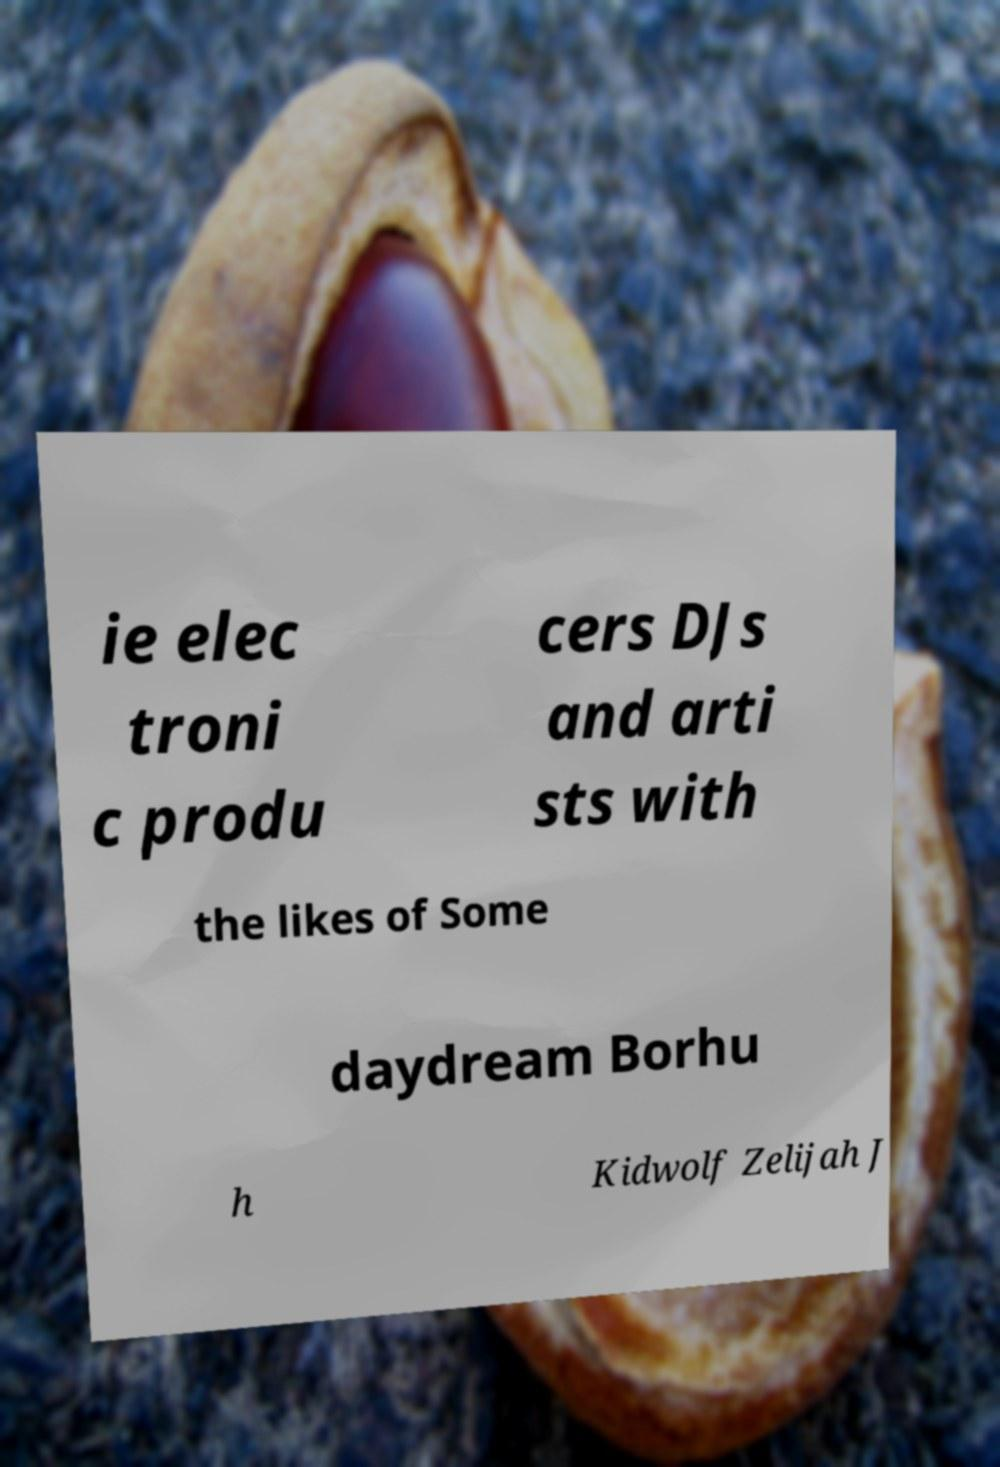Please identify and transcribe the text found in this image. ie elec troni c produ cers DJs and arti sts with the likes of Some daydream Borhu h Kidwolf Zelijah J 